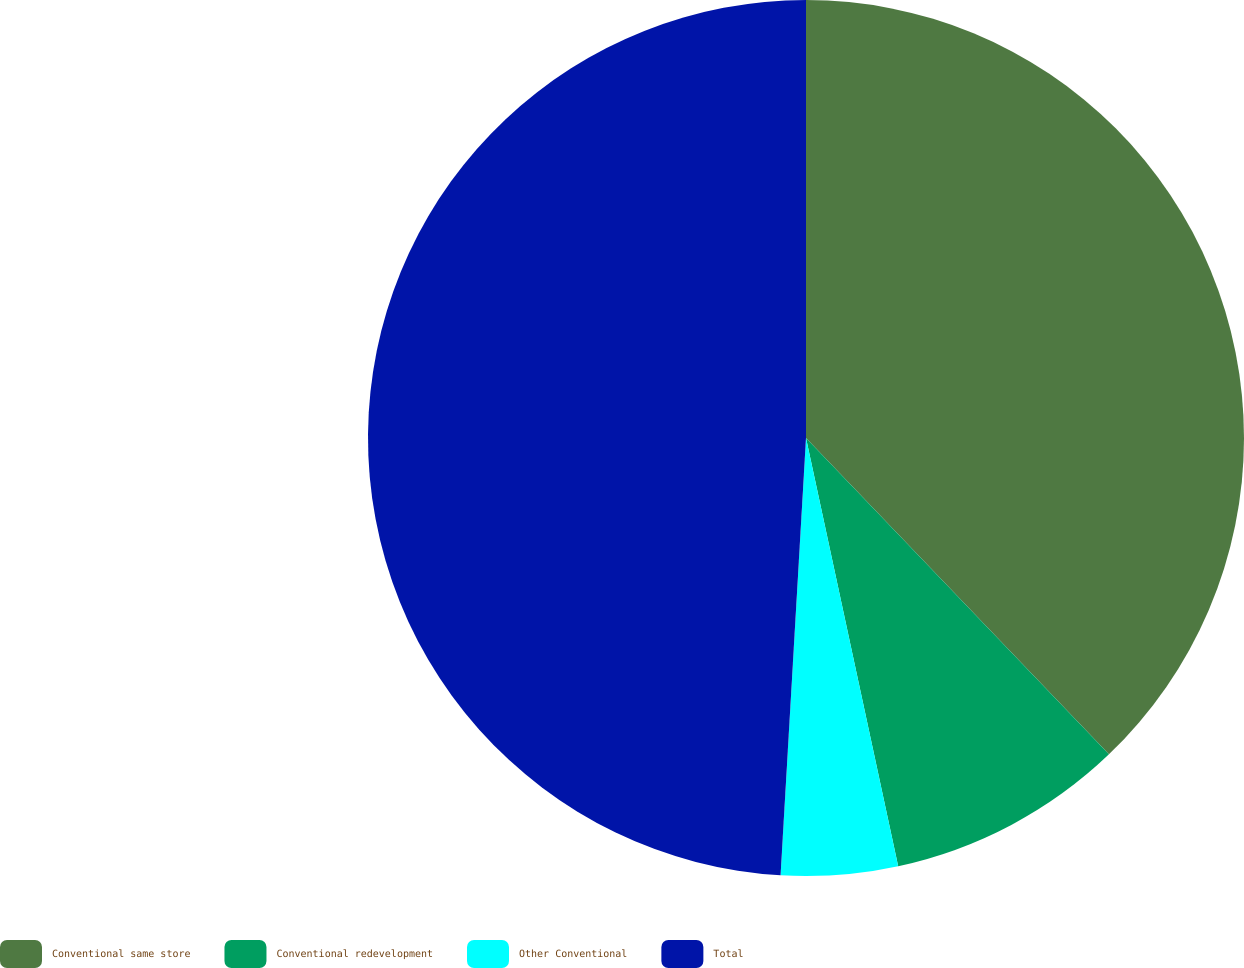Convert chart. <chart><loc_0><loc_0><loc_500><loc_500><pie_chart><fcel>Conventional same store<fcel>Conventional redevelopment<fcel>Other Conventional<fcel>Total<nl><fcel>37.84%<fcel>8.78%<fcel>4.3%<fcel>49.07%<nl></chart> 